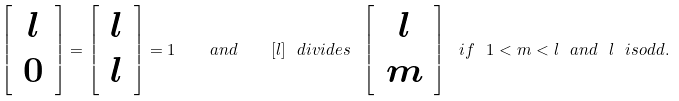<formula> <loc_0><loc_0><loc_500><loc_500>\left [ \, \begin{array} { c } l \\ 0 \end{array} \, \right ] = \left [ \, \begin{array} { c } l \\ l \end{array} \, \right ] = 1 \quad a n d \quad [ l ] \ d i v i d e s \ \left [ \, \begin{array} { c } l \\ m \end{array} \, \right ] \ i f \ 1 < m < l \ a n d \ l \ i s o d d .</formula> 